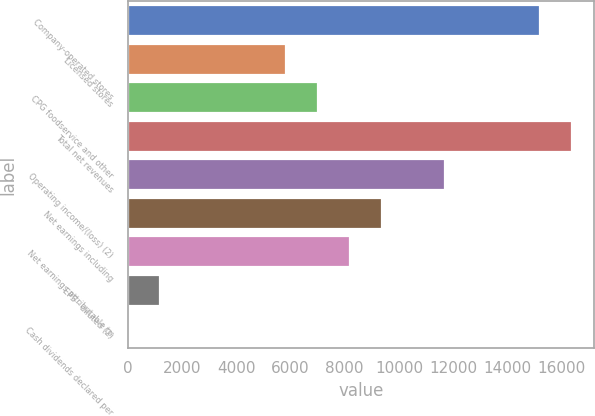<chart> <loc_0><loc_0><loc_500><loc_500><bar_chart><fcel>Company-operated stores<fcel>Licensed stores<fcel>CPG foodservice and other<fcel>Total net revenues<fcel>Operating income/(loss) (2)<fcel>Net earnings including<fcel>Net earnings attributable to<fcel>EPS - diluted (2)<fcel>Cash dividends declared per<nl><fcel>15210.4<fcel>5850.33<fcel>7020.34<fcel>16380.4<fcel>11700.4<fcel>9360.36<fcel>8190.35<fcel>1170.29<fcel>0.28<nl></chart> 